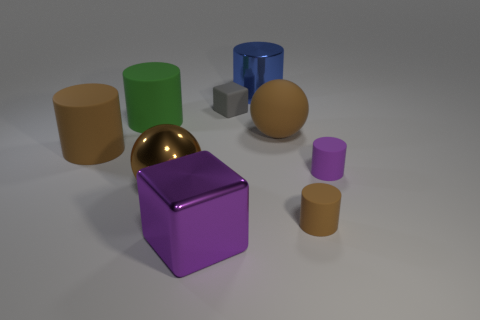What is the large brown cylinder made of?
Give a very brief answer. Rubber. What number of small objects are either blue cylinders or brown spheres?
Provide a succinct answer. 0. There is a big matte cylinder in front of the rubber sphere; does it have the same color as the metallic sphere?
Make the answer very short. Yes. There is a matte cylinder that is left of the big green object; is its color the same as the ball on the left side of the large purple shiny object?
Offer a terse response. Yes. Is there a ball made of the same material as the big purple cube?
Ensure brevity in your answer.  Yes. What number of green objects are large cylinders or metal cylinders?
Your answer should be very brief. 1. Is the number of big matte things right of the large purple metal block greater than the number of tiny cyan rubber balls?
Provide a succinct answer. Yes. Do the brown metal sphere and the gray rubber block have the same size?
Make the answer very short. No. What color is the small cylinder that is made of the same material as the small brown thing?
Your response must be concise. Purple. What shape is the thing that is the same color as the metallic cube?
Make the answer very short. Cylinder. 